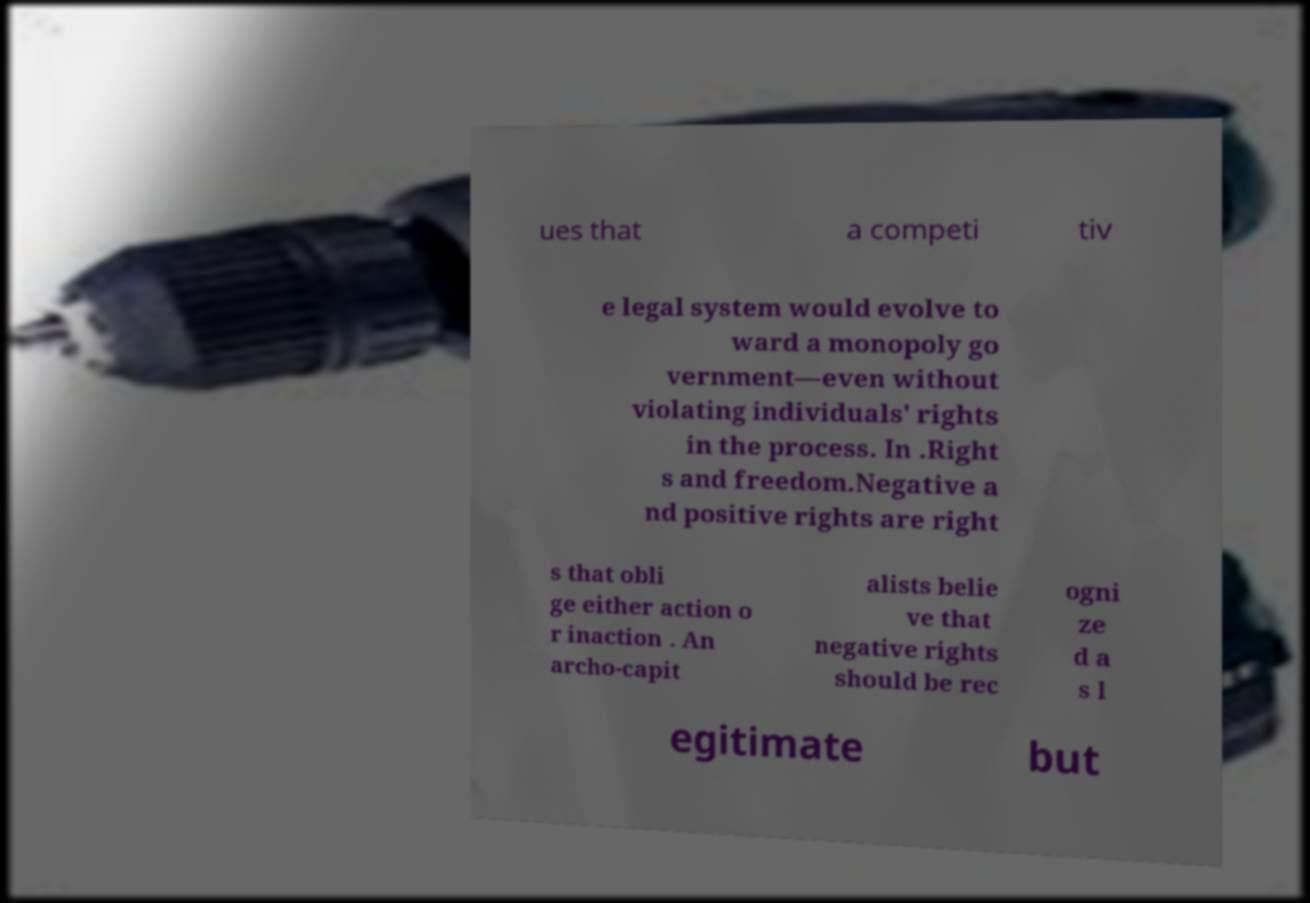Could you assist in decoding the text presented in this image and type it out clearly? ues that a competi tiv e legal system would evolve to ward a monopoly go vernment—even without violating individuals' rights in the process. In .Right s and freedom.Negative a nd positive rights are right s that obli ge either action o r inaction . An archo-capit alists belie ve that negative rights should be rec ogni ze d a s l egitimate but 